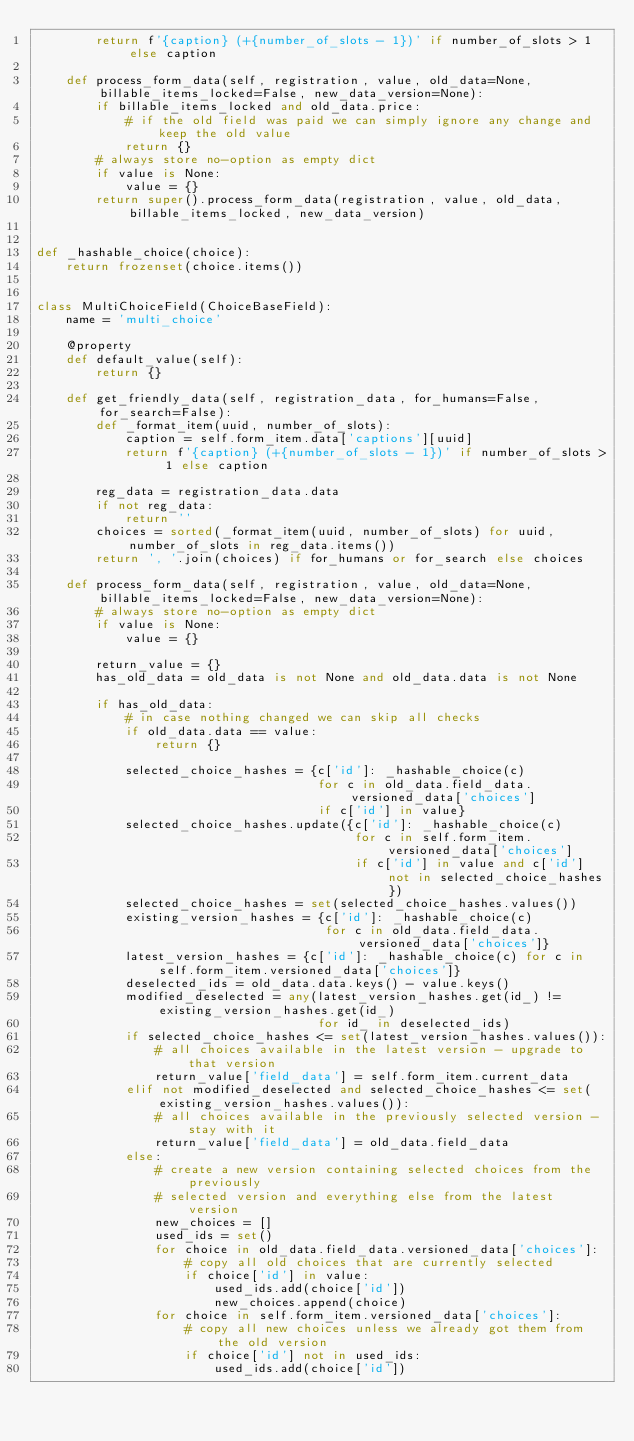<code> <loc_0><loc_0><loc_500><loc_500><_Python_>        return f'{caption} (+{number_of_slots - 1})' if number_of_slots > 1 else caption

    def process_form_data(self, registration, value, old_data=None, billable_items_locked=False, new_data_version=None):
        if billable_items_locked and old_data.price:
            # if the old field was paid we can simply ignore any change and keep the old value
            return {}
        # always store no-option as empty dict
        if value is None:
            value = {}
        return super().process_form_data(registration, value, old_data, billable_items_locked, new_data_version)


def _hashable_choice(choice):
    return frozenset(choice.items())


class MultiChoiceField(ChoiceBaseField):
    name = 'multi_choice'

    @property
    def default_value(self):
        return {}

    def get_friendly_data(self, registration_data, for_humans=False, for_search=False):
        def _format_item(uuid, number_of_slots):
            caption = self.form_item.data['captions'][uuid]
            return f'{caption} (+{number_of_slots - 1})' if number_of_slots > 1 else caption

        reg_data = registration_data.data
        if not reg_data:
            return ''
        choices = sorted(_format_item(uuid, number_of_slots) for uuid, number_of_slots in reg_data.items())
        return ', '.join(choices) if for_humans or for_search else choices

    def process_form_data(self, registration, value, old_data=None, billable_items_locked=False, new_data_version=None):
        # always store no-option as empty dict
        if value is None:
            value = {}

        return_value = {}
        has_old_data = old_data is not None and old_data.data is not None

        if has_old_data:
            # in case nothing changed we can skip all checks
            if old_data.data == value:
                return {}

            selected_choice_hashes = {c['id']: _hashable_choice(c)
                                      for c in old_data.field_data.versioned_data['choices']
                                      if c['id'] in value}
            selected_choice_hashes.update({c['id']: _hashable_choice(c)
                                           for c in self.form_item.versioned_data['choices']
                                           if c['id'] in value and c['id'] not in selected_choice_hashes})
            selected_choice_hashes = set(selected_choice_hashes.values())
            existing_version_hashes = {c['id']: _hashable_choice(c)
                                       for c in old_data.field_data.versioned_data['choices']}
            latest_version_hashes = {c['id']: _hashable_choice(c) for c in self.form_item.versioned_data['choices']}
            deselected_ids = old_data.data.keys() - value.keys()
            modified_deselected = any(latest_version_hashes.get(id_) != existing_version_hashes.get(id_)
                                      for id_ in deselected_ids)
            if selected_choice_hashes <= set(latest_version_hashes.values()):
                # all choices available in the latest version - upgrade to that version
                return_value['field_data'] = self.form_item.current_data
            elif not modified_deselected and selected_choice_hashes <= set(existing_version_hashes.values()):
                # all choices available in the previously selected version - stay with it
                return_value['field_data'] = old_data.field_data
            else:
                # create a new version containing selected choices from the previously
                # selected version and everything else from the latest version
                new_choices = []
                used_ids = set()
                for choice in old_data.field_data.versioned_data['choices']:
                    # copy all old choices that are currently selected
                    if choice['id'] in value:
                        used_ids.add(choice['id'])
                        new_choices.append(choice)
                for choice in self.form_item.versioned_data['choices']:
                    # copy all new choices unless we already got them from the old version
                    if choice['id'] not in used_ids:
                        used_ids.add(choice['id'])</code> 